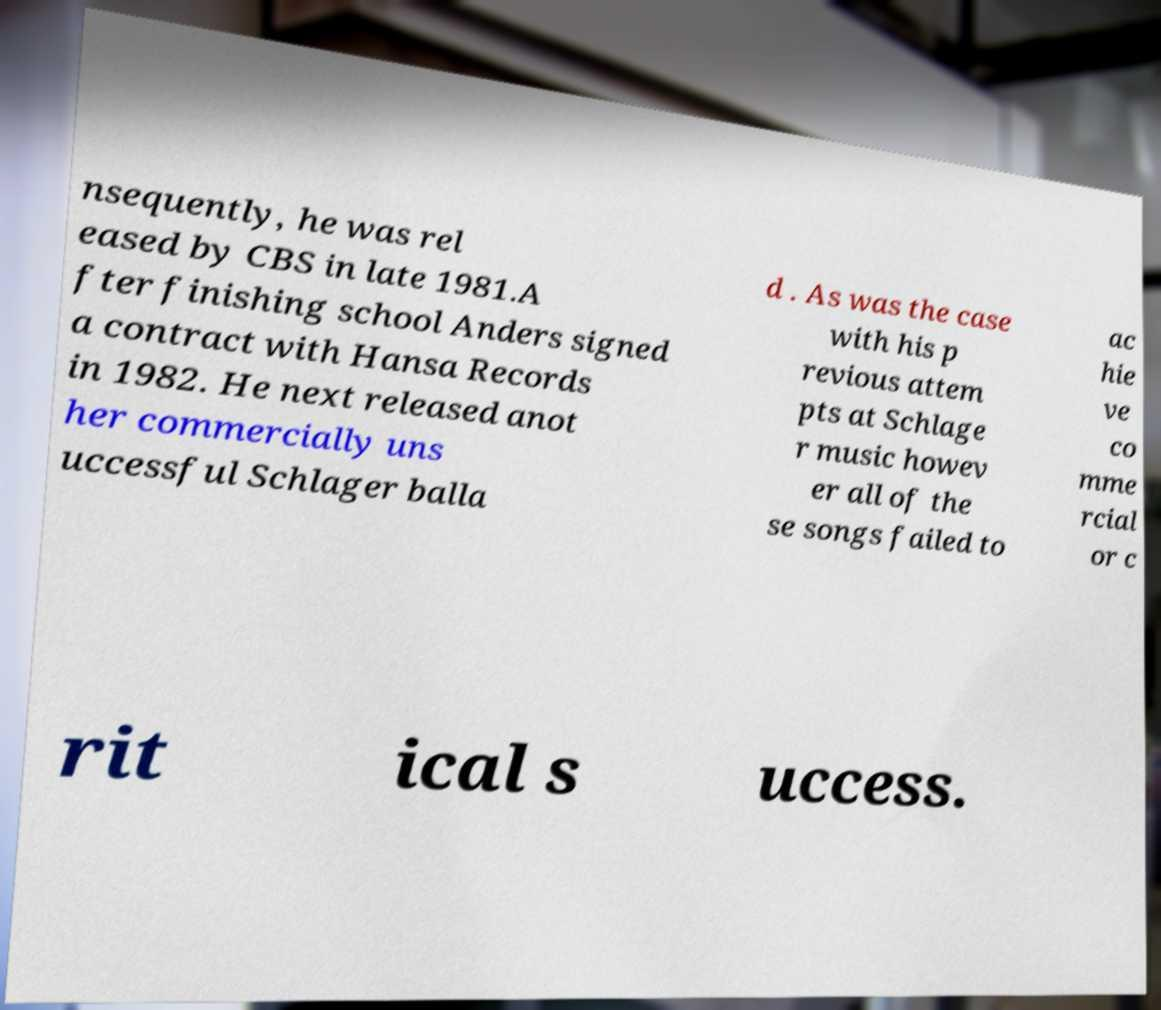I need the written content from this picture converted into text. Can you do that? nsequently, he was rel eased by CBS in late 1981.A fter finishing school Anders signed a contract with Hansa Records in 1982. He next released anot her commercially uns uccessful Schlager balla d . As was the case with his p revious attem pts at Schlage r music howev er all of the se songs failed to ac hie ve co mme rcial or c rit ical s uccess. 